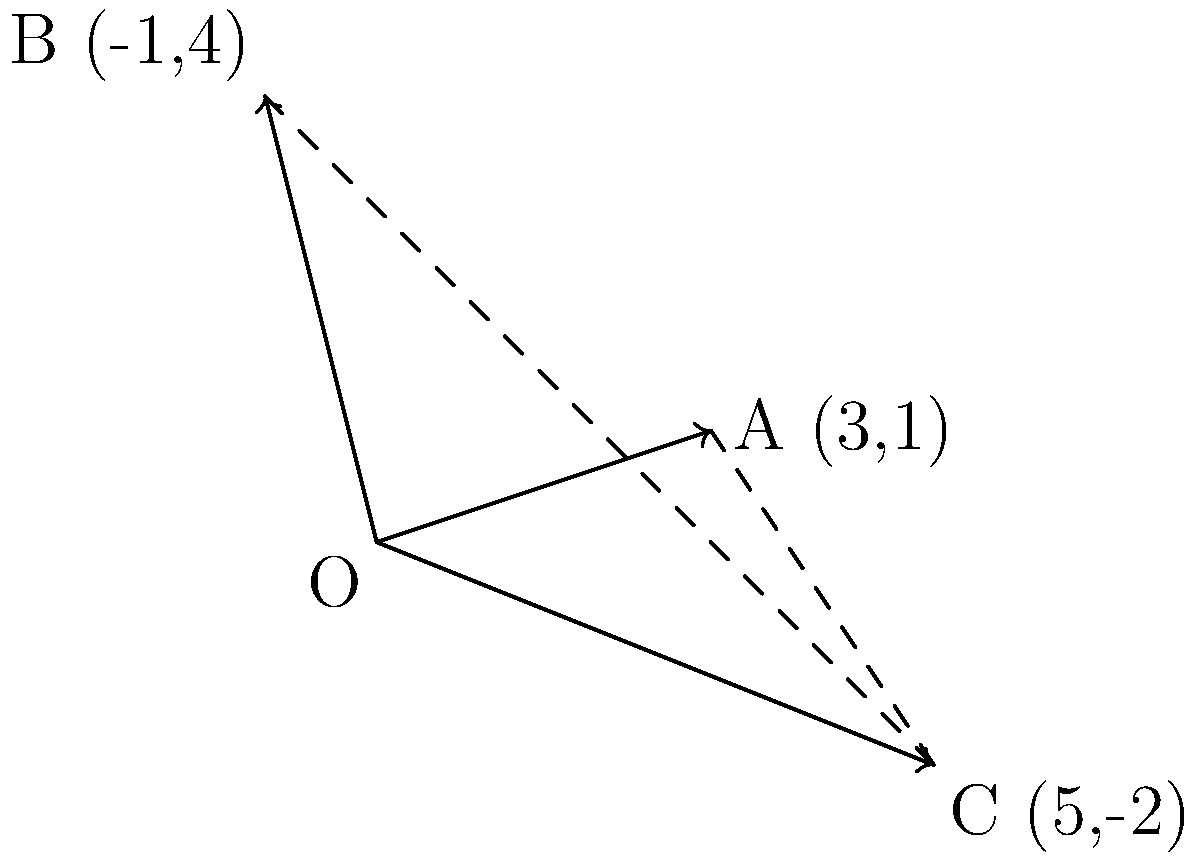As a humanitarian aid worker, you're coordinating the distribution of supplies to three locations: A(3,1), B(-1,4), and C(5,-2). Each vector represents the direction and distance from the origin to a distribution point. Calculate the resultant vector that represents the overall displacement from the origin to reach all three locations efficiently. To find the resultant vector, we need to add all individual vectors. Let's approach this step-by-step:

1) First, let's identify our vectors:
   Vector OA = (3,1)
   Vector OB = (-1,4)
   Vector OC = (5,-2)

2) To add these vectors, we sum their x and y components separately:
   
   x-component: 3 + (-1) + 5 = 7
   y-component: 1 + 4 + (-2) = 3

3) Therefore, the resultant vector R is:
   R = (7,3)

4) We can verify this graphically by observing that the resultant vector indeed ends at the point (7,3) relative to the origin.

5) The magnitude of this vector can be calculated using the Pythagorean theorem:
   |R| = $\sqrt{7^2 + 3^2} = \sqrt{58} \approx 7.62$ units

6) The direction of the vector can be found using the arctangent function:
   $\theta = \tan^{-1}(\frac{3}{7}) \approx 23.2°$

Therefore, the resultant vector is (7,3), with a magnitude of approximately 7.62 units and direction of about 23.2° from the positive x-axis.
Answer: (7,3) 